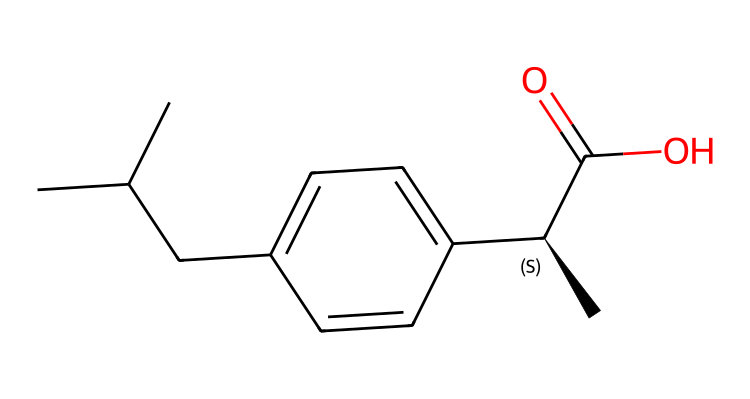What is the total number of carbon atoms in ibuprofen? Counting the carbon (C) symbols in the SMILES representation, we find there are 13 carbon atoms in total, as each 'C' indicates a carbon atom present in the structure.
Answer: 13 How many chiral centers are present in ibuprofen? In the SMILES representation, the '@' symbol indicates a chiral center at the C atom with the notation '[C@H]'. This indicates that there is one chiral center in ibuprofen.
Answer: 1 What is the functional group present in ibuprofen responsible for its acidic properties? The presence of 'C(=O)O' in the SMILES indicates a carboxylic acid functional group (–COOH), which is responsible for its acidic properties.
Answer: carboxylic acid What is the molecular formula of ibuprofen? To derive the molecular formula, we add up the atoms counted in the SMILES: 13 carbon, 18 hydrogen, and 2 oxygen atoms, giving us C13H18O2 as the molecular formula for ibuprofen.
Answer: C13H18O2 Which part of the ibuprofen structure contributes to its chiral nature? The '[C@H]' notation indicates that there is a specific carbon atom connected to four different groups in ibuprofen, which contributes to its chiral nature and optically active characteristics.
Answer: [C@H] What type of compound is ibuprofen categorized as based on its structure? Given the existence of a chiral center and multiple stereoisomers, ibuprofen is categorized as a chiral compound, specifically an active pharmaceutical ingredient.
Answer: chiral compound 